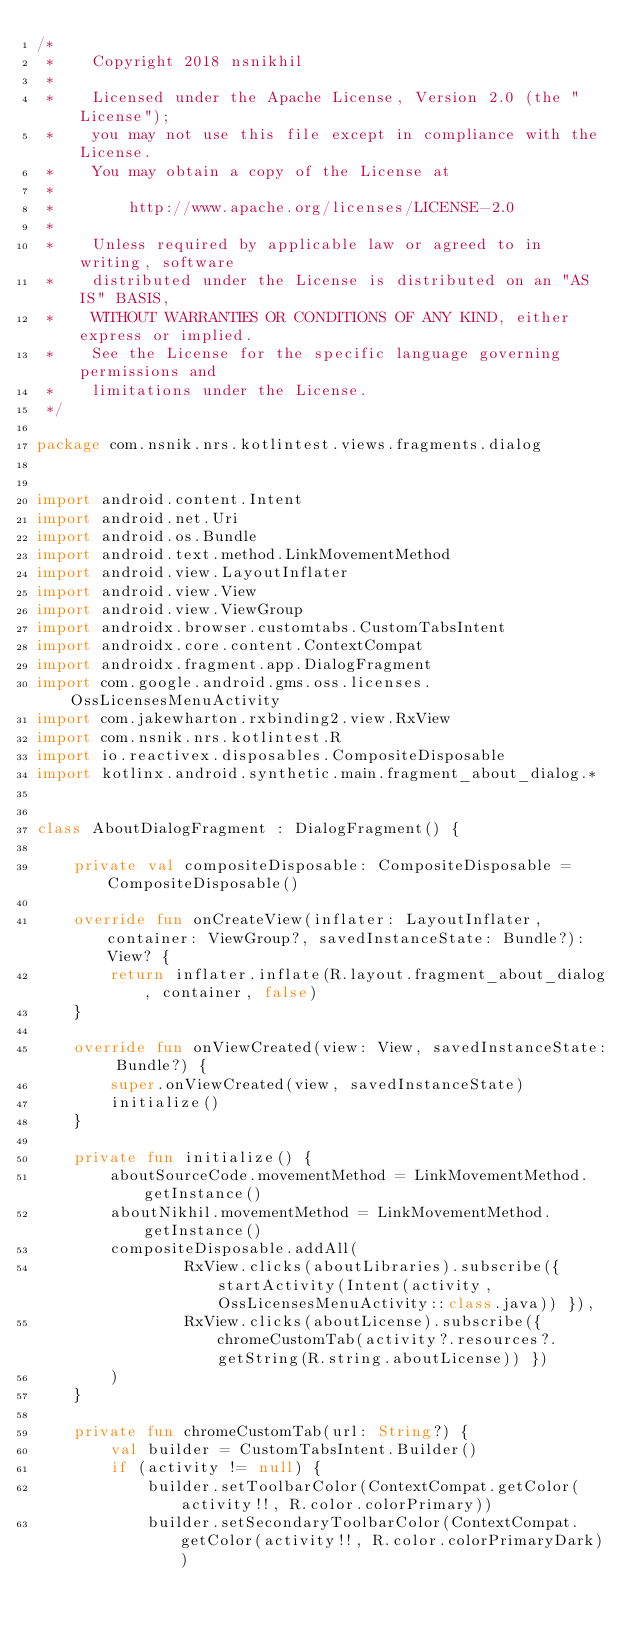Convert code to text. <code><loc_0><loc_0><loc_500><loc_500><_Kotlin_>/*
 *    Copyright 2018 nsnikhil
 *
 *    Licensed under the Apache License, Version 2.0 (the "License");
 *    you may not use this file except in compliance with the License.
 *    You may obtain a copy of the License at
 *
 *        http://www.apache.org/licenses/LICENSE-2.0
 *
 *    Unless required by applicable law or agreed to in writing, software
 *    distributed under the License is distributed on an "AS IS" BASIS,
 *    WITHOUT WARRANTIES OR CONDITIONS OF ANY KIND, either express or implied.
 *    See the License for the specific language governing permissions and
 *    limitations under the License.
 */

package com.nsnik.nrs.kotlintest.views.fragments.dialog


import android.content.Intent
import android.net.Uri
import android.os.Bundle
import android.text.method.LinkMovementMethod
import android.view.LayoutInflater
import android.view.View
import android.view.ViewGroup
import androidx.browser.customtabs.CustomTabsIntent
import androidx.core.content.ContextCompat
import androidx.fragment.app.DialogFragment
import com.google.android.gms.oss.licenses.OssLicensesMenuActivity
import com.jakewharton.rxbinding2.view.RxView
import com.nsnik.nrs.kotlintest.R
import io.reactivex.disposables.CompositeDisposable
import kotlinx.android.synthetic.main.fragment_about_dialog.*


class AboutDialogFragment : DialogFragment() {

    private val compositeDisposable: CompositeDisposable = CompositeDisposable()

    override fun onCreateView(inflater: LayoutInflater, container: ViewGroup?, savedInstanceState: Bundle?): View? {
        return inflater.inflate(R.layout.fragment_about_dialog, container, false)
    }

    override fun onViewCreated(view: View, savedInstanceState: Bundle?) {
        super.onViewCreated(view, savedInstanceState)
        initialize()
    }

    private fun initialize() {
        aboutSourceCode.movementMethod = LinkMovementMethod.getInstance()
        aboutNikhil.movementMethod = LinkMovementMethod.getInstance()
        compositeDisposable.addAll(
                RxView.clicks(aboutLibraries).subscribe({ startActivity(Intent(activity, OssLicensesMenuActivity::class.java)) }),
                RxView.clicks(aboutLicense).subscribe({ chromeCustomTab(activity?.resources?.getString(R.string.aboutLicense)) })
        )
    }

    private fun chromeCustomTab(url: String?) {
        val builder = CustomTabsIntent.Builder()
        if (activity != null) {
            builder.setToolbarColor(ContextCompat.getColor(activity!!, R.color.colorPrimary))
            builder.setSecondaryToolbarColor(ContextCompat.getColor(activity!!, R.color.colorPrimaryDark))</code> 